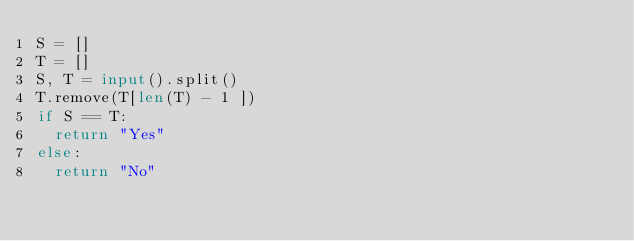Convert code to text. <code><loc_0><loc_0><loc_500><loc_500><_Python_>S = []
T = []
S, T = input().split()
T.remove(T[len(T) - 1 ])
if S == T:
  return "Yes"
else:
  return "No"</code> 